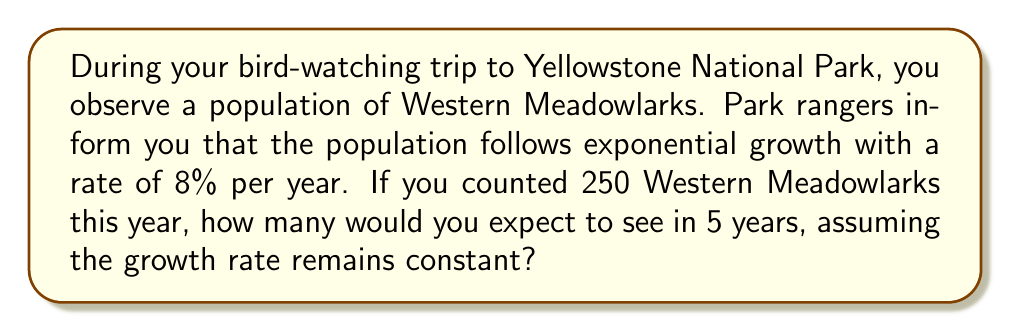Teach me how to tackle this problem. To solve this problem, we'll use the exponential growth formula:

$$N(t) = N_0 \cdot e^{rt}$$

Where:
$N(t)$ is the population size at time $t$
$N_0$ is the initial population size
$e$ is Euler's number (approximately 2.71828)
$r$ is the growth rate (as a decimal)
$t$ is the time period

Given:
$N_0 = 250$ (initial population)
$r = 0.08$ (8% growth rate as a decimal)
$t = 5$ years

Let's plug these values into the formula:

$$N(5) = 250 \cdot e^{0.08 \cdot 5}$$

Now, let's calculate:

1) First, multiply $0.08 \cdot 5 = 0.4$
2) Calculate $e^{0.4}$:
   $$e^{0.4} \approx 1.4918$$
3) Multiply this by the initial population:
   $$250 \cdot 1.4918 \approx 372.95$$

4) Round to the nearest whole number, as we can't have a fraction of a bird.

Therefore, after 5 years, you would expect to see approximately 373 Western Meadowlarks.
Answer: 373 Western Meadowlarks 